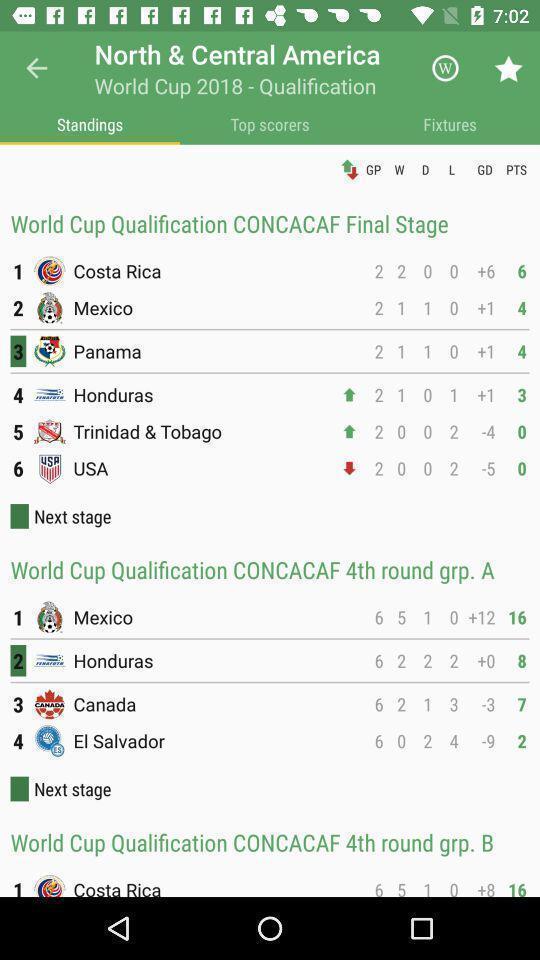Describe the content in this image. Score card of various sport teams. 